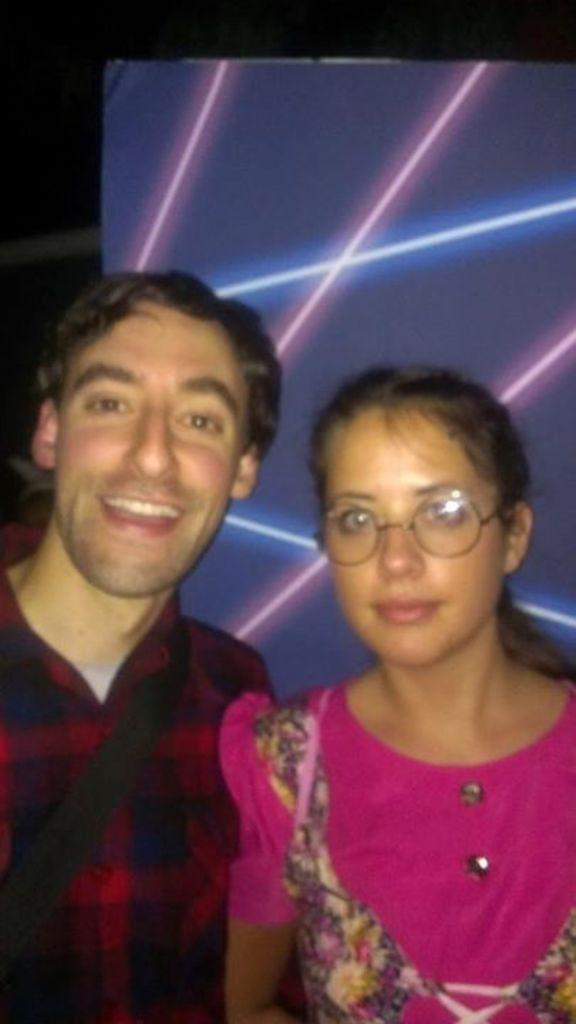How many people are present in the image? There is a man and a woman in the image. What can be seen in the background of the image? Lights are visible in the background of the image. What type of house does the manager live in, as seen in the image? There is no house or manager present in the image. 